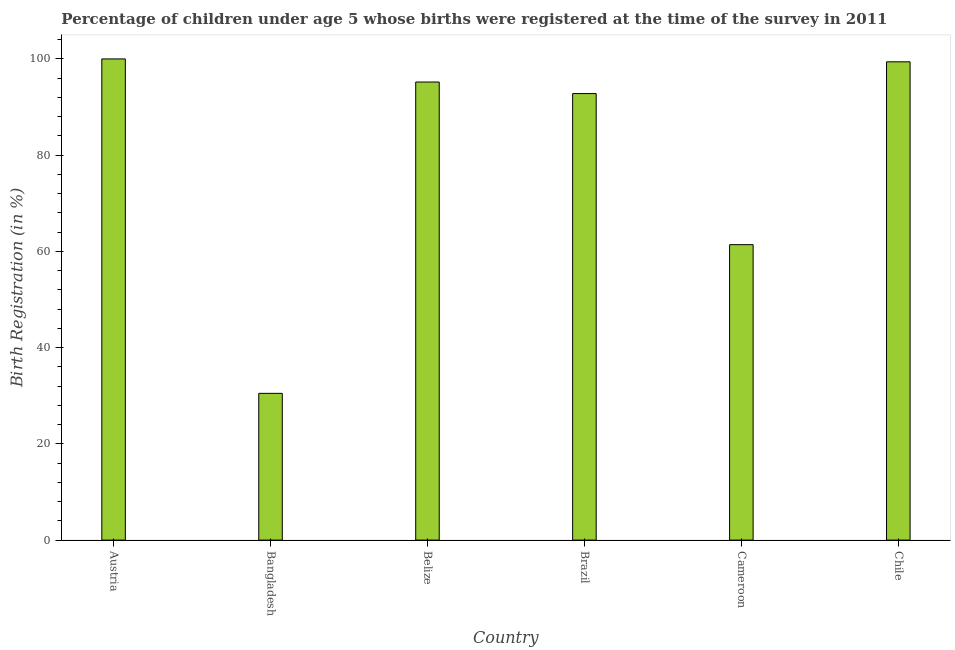Does the graph contain grids?
Your response must be concise. No. What is the title of the graph?
Your answer should be very brief. Percentage of children under age 5 whose births were registered at the time of the survey in 2011. What is the label or title of the X-axis?
Your response must be concise. Country. What is the label or title of the Y-axis?
Give a very brief answer. Birth Registration (in %). What is the birth registration in Belize?
Provide a succinct answer. 95.2. Across all countries, what is the maximum birth registration?
Make the answer very short. 100. Across all countries, what is the minimum birth registration?
Your response must be concise. 30.5. In which country was the birth registration minimum?
Ensure brevity in your answer.  Bangladesh. What is the sum of the birth registration?
Make the answer very short. 479.3. What is the average birth registration per country?
Provide a short and direct response. 79.88. What is the median birth registration?
Offer a terse response. 94. Is the birth registration in Brazil less than that in Chile?
Keep it short and to the point. Yes. What is the difference between the highest and the lowest birth registration?
Offer a terse response. 69.5. In how many countries, is the birth registration greater than the average birth registration taken over all countries?
Your response must be concise. 4. How many countries are there in the graph?
Provide a short and direct response. 6. What is the difference between two consecutive major ticks on the Y-axis?
Keep it short and to the point. 20. What is the Birth Registration (in %) of Austria?
Your answer should be very brief. 100. What is the Birth Registration (in %) of Bangladesh?
Your answer should be compact. 30.5. What is the Birth Registration (in %) in Belize?
Keep it short and to the point. 95.2. What is the Birth Registration (in %) of Brazil?
Your answer should be very brief. 92.8. What is the Birth Registration (in %) of Cameroon?
Offer a terse response. 61.4. What is the Birth Registration (in %) in Chile?
Offer a terse response. 99.4. What is the difference between the Birth Registration (in %) in Austria and Bangladesh?
Your answer should be very brief. 69.5. What is the difference between the Birth Registration (in %) in Austria and Brazil?
Your response must be concise. 7.2. What is the difference between the Birth Registration (in %) in Austria and Cameroon?
Offer a terse response. 38.6. What is the difference between the Birth Registration (in %) in Austria and Chile?
Provide a succinct answer. 0.6. What is the difference between the Birth Registration (in %) in Bangladesh and Belize?
Offer a very short reply. -64.7. What is the difference between the Birth Registration (in %) in Bangladesh and Brazil?
Make the answer very short. -62.3. What is the difference between the Birth Registration (in %) in Bangladesh and Cameroon?
Provide a succinct answer. -30.9. What is the difference between the Birth Registration (in %) in Bangladesh and Chile?
Your response must be concise. -68.9. What is the difference between the Birth Registration (in %) in Belize and Cameroon?
Your response must be concise. 33.8. What is the difference between the Birth Registration (in %) in Belize and Chile?
Give a very brief answer. -4.2. What is the difference between the Birth Registration (in %) in Brazil and Cameroon?
Your response must be concise. 31.4. What is the difference between the Birth Registration (in %) in Cameroon and Chile?
Provide a short and direct response. -38. What is the ratio of the Birth Registration (in %) in Austria to that in Bangladesh?
Your answer should be compact. 3.28. What is the ratio of the Birth Registration (in %) in Austria to that in Belize?
Offer a terse response. 1.05. What is the ratio of the Birth Registration (in %) in Austria to that in Brazil?
Offer a terse response. 1.08. What is the ratio of the Birth Registration (in %) in Austria to that in Cameroon?
Offer a very short reply. 1.63. What is the ratio of the Birth Registration (in %) in Austria to that in Chile?
Make the answer very short. 1.01. What is the ratio of the Birth Registration (in %) in Bangladesh to that in Belize?
Offer a very short reply. 0.32. What is the ratio of the Birth Registration (in %) in Bangladesh to that in Brazil?
Offer a terse response. 0.33. What is the ratio of the Birth Registration (in %) in Bangladesh to that in Cameroon?
Provide a succinct answer. 0.5. What is the ratio of the Birth Registration (in %) in Bangladesh to that in Chile?
Your response must be concise. 0.31. What is the ratio of the Birth Registration (in %) in Belize to that in Cameroon?
Give a very brief answer. 1.55. What is the ratio of the Birth Registration (in %) in Belize to that in Chile?
Keep it short and to the point. 0.96. What is the ratio of the Birth Registration (in %) in Brazil to that in Cameroon?
Provide a short and direct response. 1.51. What is the ratio of the Birth Registration (in %) in Brazil to that in Chile?
Offer a terse response. 0.93. What is the ratio of the Birth Registration (in %) in Cameroon to that in Chile?
Provide a short and direct response. 0.62. 